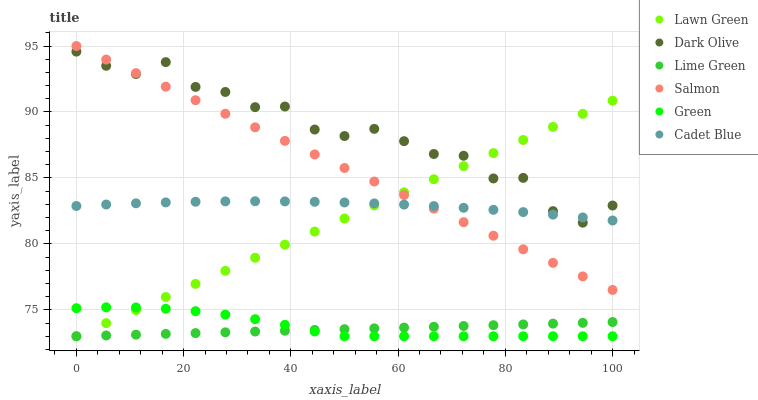Does Lime Green have the minimum area under the curve?
Answer yes or no. Yes. Does Dark Olive have the maximum area under the curve?
Answer yes or no. Yes. Does Cadet Blue have the minimum area under the curve?
Answer yes or no. No. Does Cadet Blue have the maximum area under the curve?
Answer yes or no. No. Is Lawn Green the smoothest?
Answer yes or no. Yes. Is Dark Olive the roughest?
Answer yes or no. Yes. Is Cadet Blue the smoothest?
Answer yes or no. No. Is Cadet Blue the roughest?
Answer yes or no. No. Does Lawn Green have the lowest value?
Answer yes or no. Yes. Does Dark Olive have the lowest value?
Answer yes or no. No. Does Salmon have the highest value?
Answer yes or no. Yes. Does Cadet Blue have the highest value?
Answer yes or no. No. Is Lime Green less than Dark Olive?
Answer yes or no. Yes. Is Salmon greater than Lime Green?
Answer yes or no. Yes. Does Lawn Green intersect Cadet Blue?
Answer yes or no. Yes. Is Lawn Green less than Cadet Blue?
Answer yes or no. No. Is Lawn Green greater than Cadet Blue?
Answer yes or no. No. Does Lime Green intersect Dark Olive?
Answer yes or no. No. 